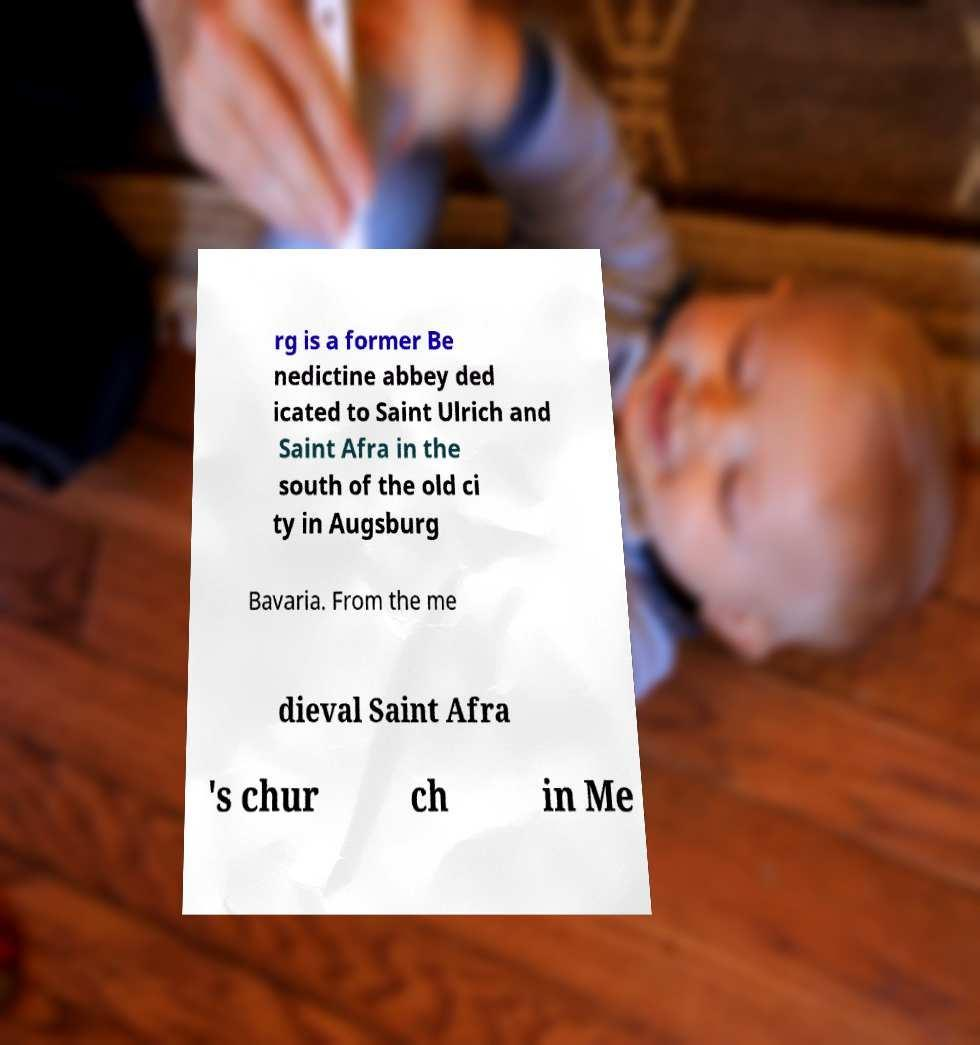Could you extract and type out the text from this image? rg is a former Be nedictine abbey ded icated to Saint Ulrich and Saint Afra in the south of the old ci ty in Augsburg Bavaria. From the me dieval Saint Afra 's chur ch in Me 